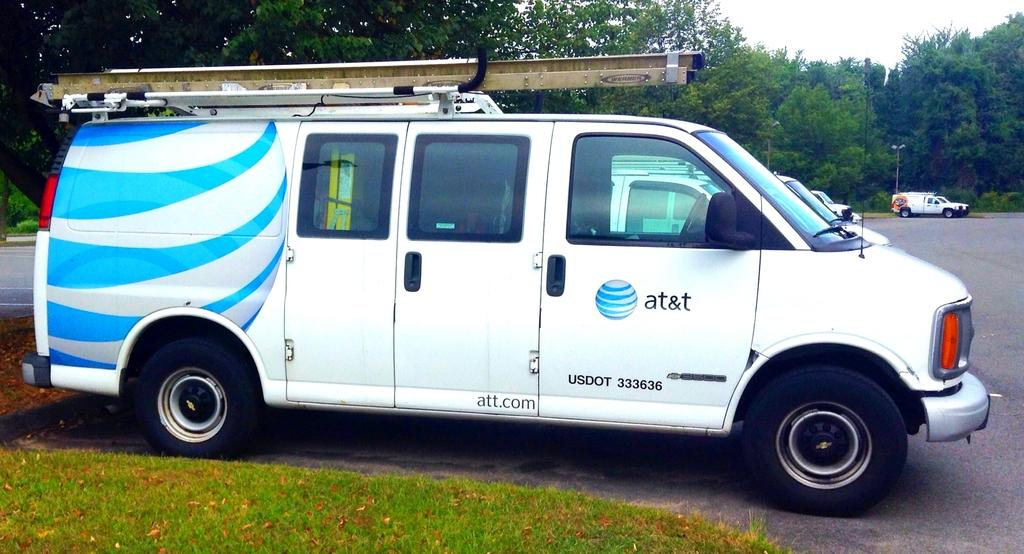<image>
Provide a brief description of the given image. the word at&t that is on a truck 